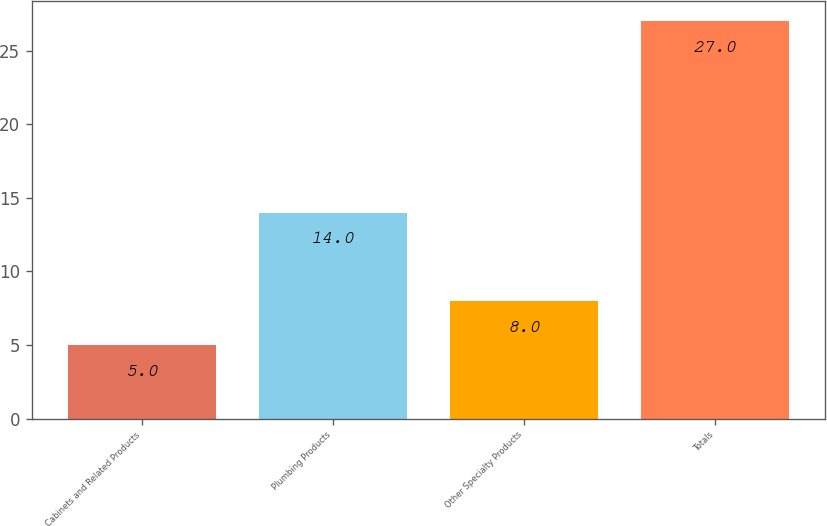Convert chart to OTSL. <chart><loc_0><loc_0><loc_500><loc_500><bar_chart><fcel>Cabinets and Related Products<fcel>Plumbing Products<fcel>Other Specialty Products<fcel>Totals<nl><fcel>5<fcel>14<fcel>8<fcel>27<nl></chart> 